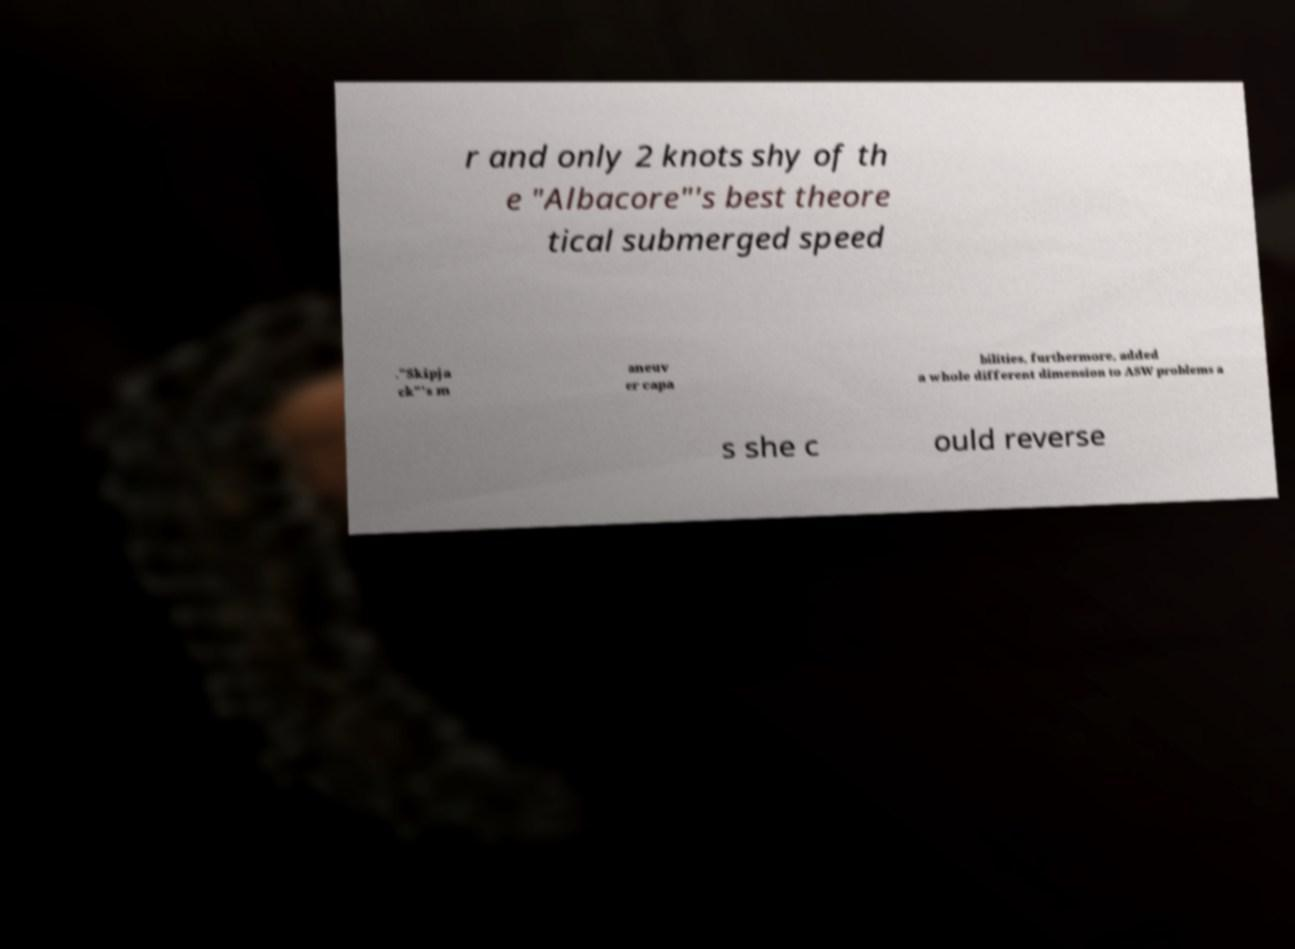Please identify and transcribe the text found in this image. r and only 2 knots shy of th e "Albacore"'s best theore tical submerged speed ."Skipja ck"'s m aneuv er capa bilities, furthermore, added a whole different dimension to ASW problems a s she c ould reverse 